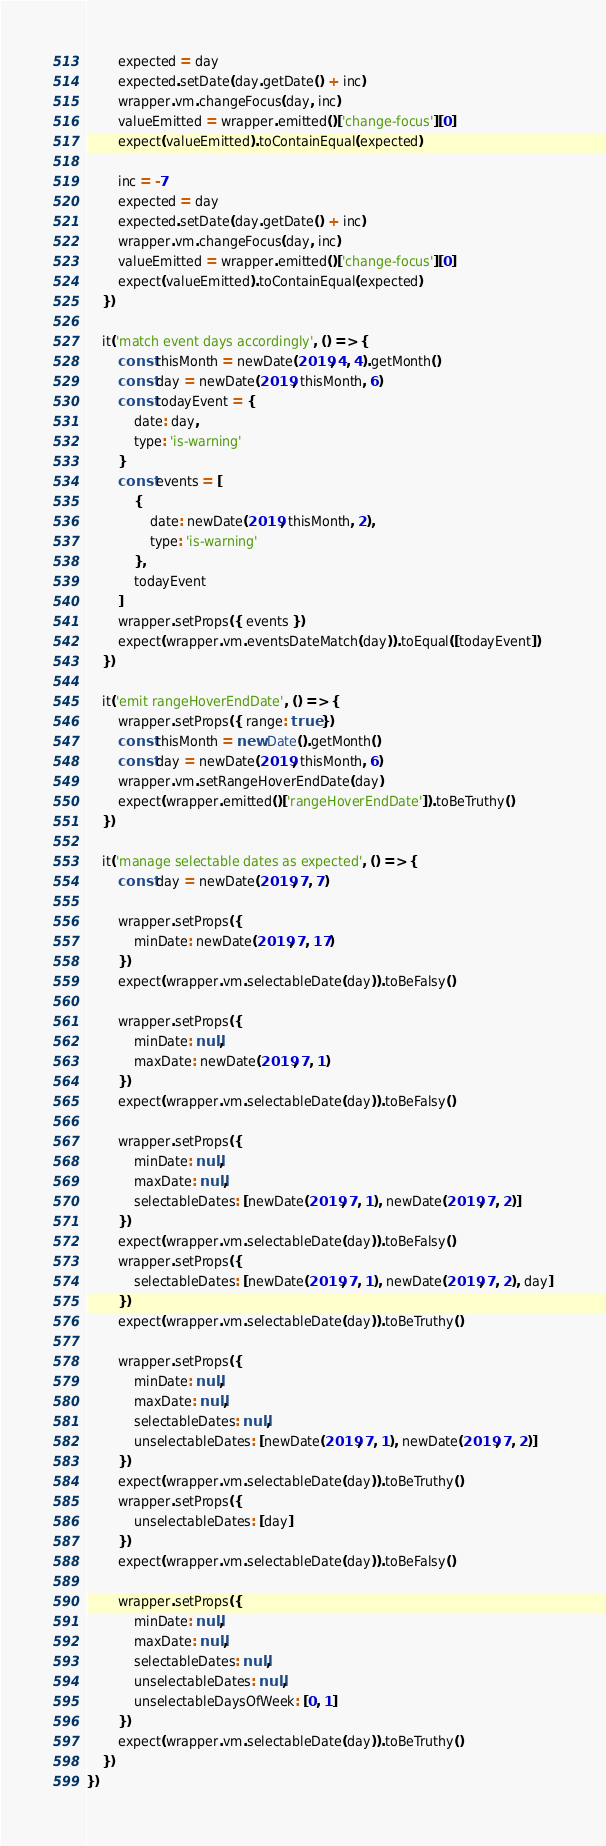Convert code to text. <code><loc_0><loc_0><loc_500><loc_500><_JavaScript_>        expected = day
        expected.setDate(day.getDate() + inc)
        wrapper.vm.changeFocus(day, inc)
        valueEmitted = wrapper.emitted()['change-focus'][0]
        expect(valueEmitted).toContainEqual(expected)

        inc = -7
        expected = day
        expected.setDate(day.getDate() + inc)
        wrapper.vm.changeFocus(day, inc)
        valueEmitted = wrapper.emitted()['change-focus'][0]
        expect(valueEmitted).toContainEqual(expected)
    })

    it('match event days accordingly', () => {
        const thisMonth = newDate(2019, 4, 4).getMonth()
        const day = newDate(2019, thisMonth, 6)
        const todayEvent = {
            date: day,
            type: 'is-warning'
        }
        const events = [
            {
                date: newDate(2019, thisMonth, 2),
                type: 'is-warning'
            },
            todayEvent
        ]
        wrapper.setProps({ events })
        expect(wrapper.vm.eventsDateMatch(day)).toEqual([todayEvent])
    })

    it('emit rangeHoverEndDate', () => {
        wrapper.setProps({ range: true })
        const thisMonth = new Date().getMonth()
        const day = newDate(2019, thisMonth, 6)
        wrapper.vm.setRangeHoverEndDate(day)
        expect(wrapper.emitted()['rangeHoverEndDate']).toBeTruthy()
    })

    it('manage selectable dates as expected', () => {
        const day = newDate(2019, 7, 7)

        wrapper.setProps({
            minDate: newDate(2019, 7, 17)
        })
        expect(wrapper.vm.selectableDate(day)).toBeFalsy()

        wrapper.setProps({
            minDate: null,
            maxDate: newDate(2019, 7, 1)
        })
        expect(wrapper.vm.selectableDate(day)).toBeFalsy()

        wrapper.setProps({
            minDate: null,
            maxDate: null,
            selectableDates: [newDate(2019, 7, 1), newDate(2019, 7, 2)]
        })
        expect(wrapper.vm.selectableDate(day)).toBeFalsy()
        wrapper.setProps({
            selectableDates: [newDate(2019, 7, 1), newDate(2019, 7, 2), day]
        })
        expect(wrapper.vm.selectableDate(day)).toBeTruthy()

        wrapper.setProps({
            minDate: null,
            maxDate: null,
            selectableDates: null,
            unselectableDates: [newDate(2019, 7, 1), newDate(2019, 7, 2)]
        })
        expect(wrapper.vm.selectableDate(day)).toBeTruthy()
        wrapper.setProps({
            unselectableDates: [day]
        })
        expect(wrapper.vm.selectableDate(day)).toBeFalsy()

        wrapper.setProps({
            minDate: null,
            maxDate: null,
            selectableDates: null,
            unselectableDates: null,
            unselectableDaysOfWeek: [0, 1]
        })
        expect(wrapper.vm.selectableDate(day)).toBeTruthy()
    })
})
</code> 